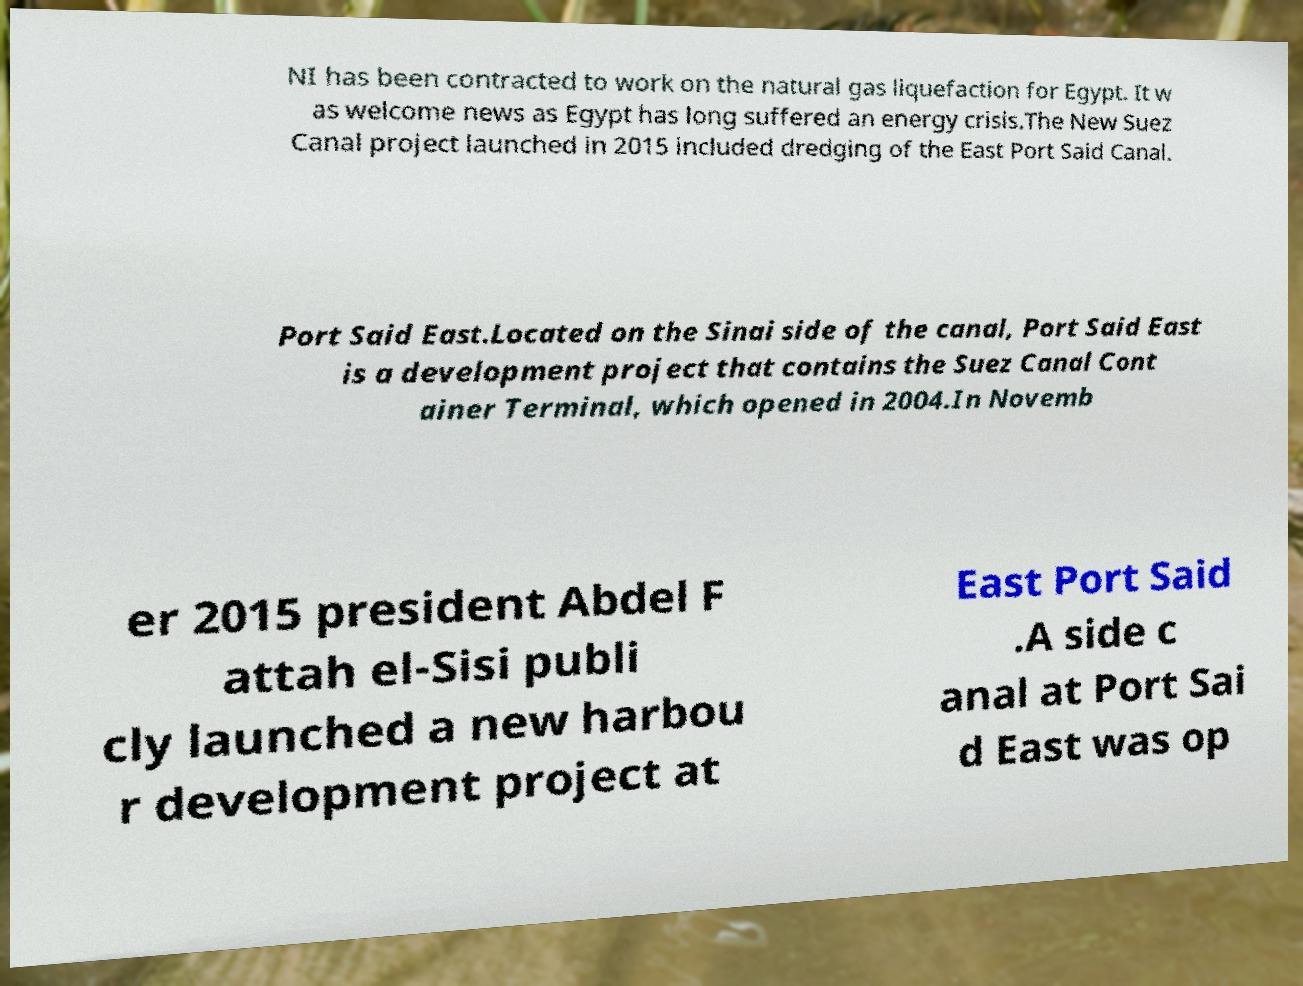Can you accurately transcribe the text from the provided image for me? NI has been contracted to work on the natural gas liquefaction for Egypt. It w as welcome news as Egypt has long suffered an energy crisis.The New Suez Canal project launched in 2015 included dredging of the East Port Said Canal. Port Said East.Located on the Sinai side of the canal, Port Said East is a development project that contains the Suez Canal Cont ainer Terminal, which opened in 2004.In Novemb er 2015 president Abdel F attah el-Sisi publi cly launched a new harbou r development project at East Port Said .A side c anal at Port Sai d East was op 